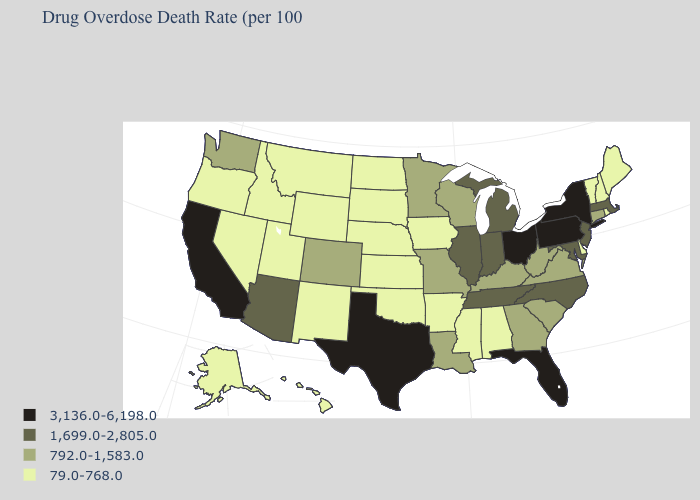Does Nebraska have the lowest value in the USA?
Write a very short answer. Yes. Does Kansas have the same value as Hawaii?
Concise answer only. Yes. Which states have the lowest value in the USA?
Write a very short answer. Alabama, Alaska, Arkansas, Delaware, Hawaii, Idaho, Iowa, Kansas, Maine, Mississippi, Montana, Nebraska, Nevada, New Hampshire, New Mexico, North Dakota, Oklahoma, Oregon, Rhode Island, South Dakota, Utah, Vermont, Wyoming. What is the value of Tennessee?
Keep it brief. 1,699.0-2,805.0. Is the legend a continuous bar?
Give a very brief answer. No. Does Florida have the lowest value in the South?
Be succinct. No. Does Kentucky have the highest value in the South?
Write a very short answer. No. What is the value of Missouri?
Concise answer only. 792.0-1,583.0. What is the value of South Carolina?
Keep it brief. 792.0-1,583.0. Among the states that border Michigan , does Wisconsin have the highest value?
Quick response, please. No. Among the states that border Connecticut , which have the highest value?
Be succinct. New York. Name the states that have a value in the range 792.0-1,583.0?
Short answer required. Colorado, Connecticut, Georgia, Kentucky, Louisiana, Minnesota, Missouri, South Carolina, Virginia, Washington, West Virginia, Wisconsin. Does New Mexico have the lowest value in the USA?
Concise answer only. Yes. Among the states that border Connecticut , which have the lowest value?
Give a very brief answer. Rhode Island. Name the states that have a value in the range 79.0-768.0?
Short answer required. Alabama, Alaska, Arkansas, Delaware, Hawaii, Idaho, Iowa, Kansas, Maine, Mississippi, Montana, Nebraska, Nevada, New Hampshire, New Mexico, North Dakota, Oklahoma, Oregon, Rhode Island, South Dakota, Utah, Vermont, Wyoming. 